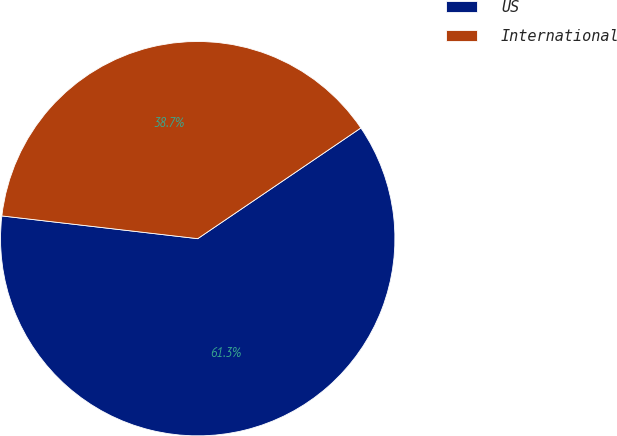<chart> <loc_0><loc_0><loc_500><loc_500><pie_chart><fcel>US<fcel>International<nl><fcel>61.33%<fcel>38.67%<nl></chart> 